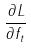Convert formula to latex. <formula><loc_0><loc_0><loc_500><loc_500>\frac { \partial L } { \partial f _ { t } }</formula> 